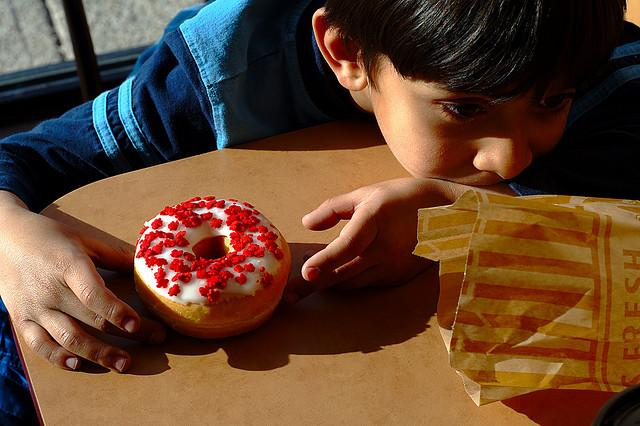When did the restaurant make this donut? recently 